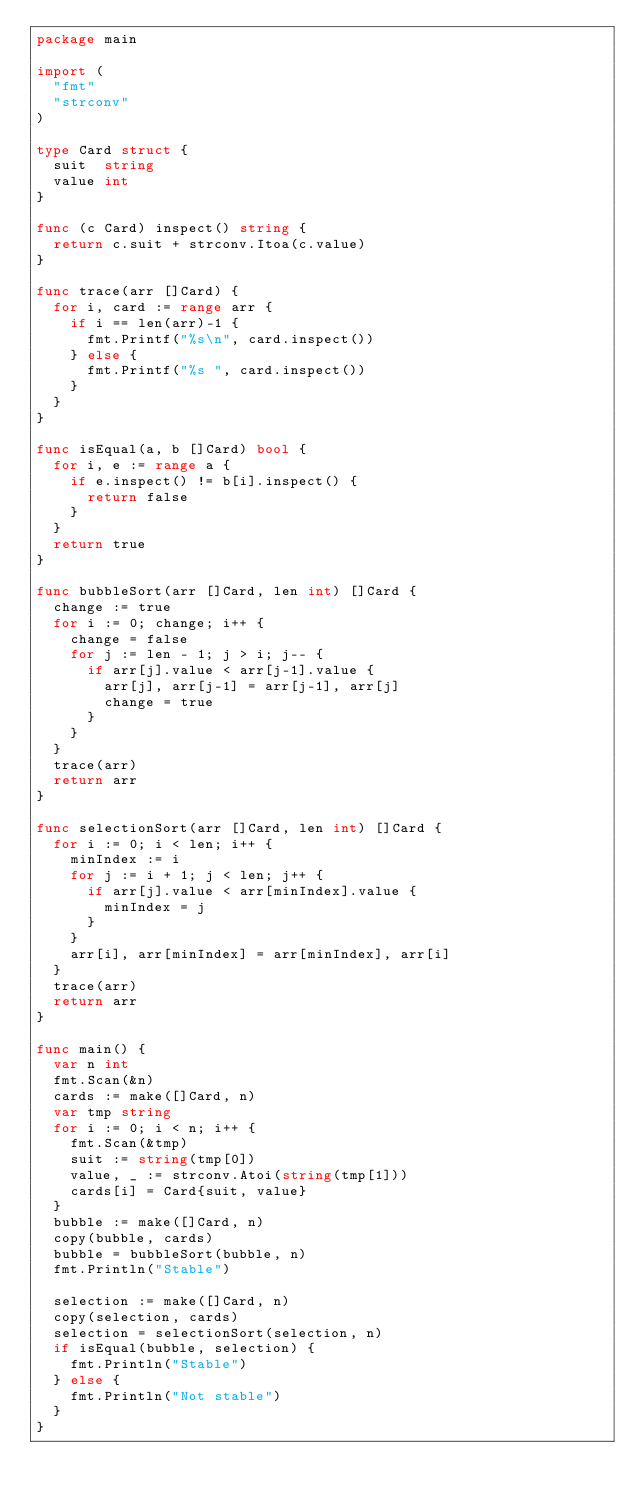<code> <loc_0><loc_0><loc_500><loc_500><_Go_>package main

import (
	"fmt"
	"strconv"
)

type Card struct {
	suit  string
	value int
}

func (c Card) inspect() string {
	return c.suit + strconv.Itoa(c.value)
}

func trace(arr []Card) {
	for i, card := range arr {
		if i == len(arr)-1 {
			fmt.Printf("%s\n", card.inspect())
		} else {
			fmt.Printf("%s ", card.inspect())
		}
	}
}

func isEqual(a, b []Card) bool {
	for i, e := range a {
		if e.inspect() != b[i].inspect() {
			return false
		}
	}
	return true
}

func bubbleSort(arr []Card, len int) []Card {
	change := true
	for i := 0; change; i++ {
		change = false
		for j := len - 1; j > i; j-- {
			if arr[j].value < arr[j-1].value {
				arr[j], arr[j-1] = arr[j-1], arr[j]
				change = true
			}
		}
	}
	trace(arr)
	return arr
}

func selectionSort(arr []Card, len int) []Card {
	for i := 0; i < len; i++ {
		minIndex := i
		for j := i + 1; j < len; j++ {
			if arr[j].value < arr[minIndex].value {
				minIndex = j
			}
		}
		arr[i], arr[minIndex] = arr[minIndex], arr[i]
	}
	trace(arr)
	return arr
}

func main() {
	var n int
	fmt.Scan(&n)
	cards := make([]Card, n)
	var tmp string
	for i := 0; i < n; i++ {
		fmt.Scan(&tmp)
		suit := string(tmp[0])
		value, _ := strconv.Atoi(string(tmp[1]))
		cards[i] = Card{suit, value}
	}
	bubble := make([]Card, n)
	copy(bubble, cards)
	bubble = bubbleSort(bubble, n)
	fmt.Println("Stable")

	selection := make([]Card, n)
	copy(selection, cards)
	selection = selectionSort(selection, n)
	if isEqual(bubble, selection) {
		fmt.Println("Stable")
	} else {
		fmt.Println("Not stable")
	}
}

</code> 